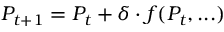<formula> <loc_0><loc_0><loc_500><loc_500>P _ { t + 1 } = P _ { t } + \delta \cdot f ( P _ { t } , \dots )</formula> 